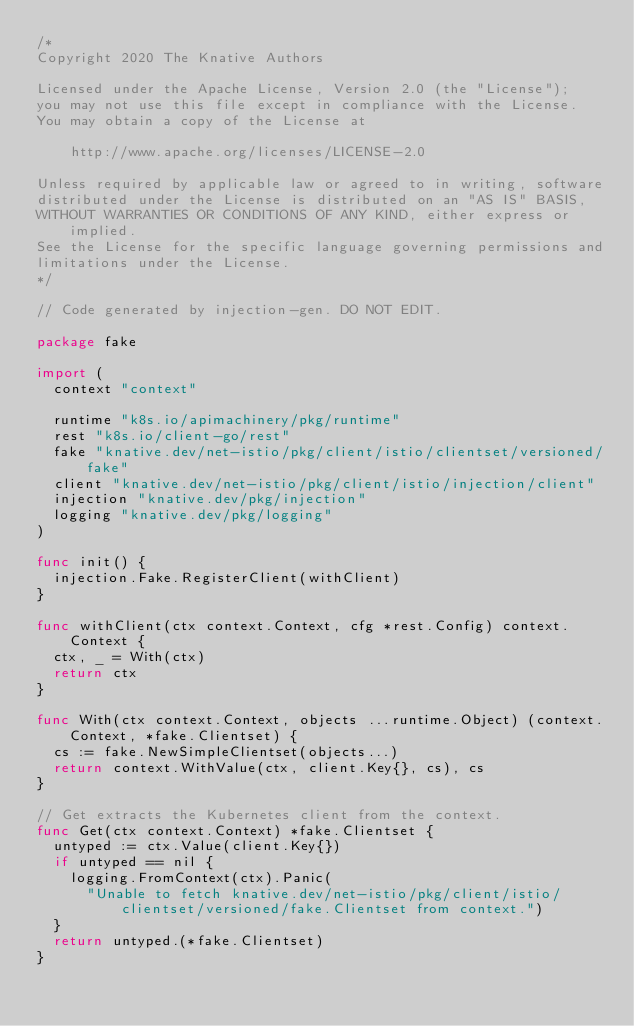Convert code to text. <code><loc_0><loc_0><loc_500><loc_500><_Go_>/*
Copyright 2020 The Knative Authors

Licensed under the Apache License, Version 2.0 (the "License");
you may not use this file except in compliance with the License.
You may obtain a copy of the License at

    http://www.apache.org/licenses/LICENSE-2.0

Unless required by applicable law or agreed to in writing, software
distributed under the License is distributed on an "AS IS" BASIS,
WITHOUT WARRANTIES OR CONDITIONS OF ANY KIND, either express or implied.
See the License for the specific language governing permissions and
limitations under the License.
*/

// Code generated by injection-gen. DO NOT EDIT.

package fake

import (
	context "context"

	runtime "k8s.io/apimachinery/pkg/runtime"
	rest "k8s.io/client-go/rest"
	fake "knative.dev/net-istio/pkg/client/istio/clientset/versioned/fake"
	client "knative.dev/net-istio/pkg/client/istio/injection/client"
	injection "knative.dev/pkg/injection"
	logging "knative.dev/pkg/logging"
)

func init() {
	injection.Fake.RegisterClient(withClient)
}

func withClient(ctx context.Context, cfg *rest.Config) context.Context {
	ctx, _ = With(ctx)
	return ctx
}

func With(ctx context.Context, objects ...runtime.Object) (context.Context, *fake.Clientset) {
	cs := fake.NewSimpleClientset(objects...)
	return context.WithValue(ctx, client.Key{}, cs), cs
}

// Get extracts the Kubernetes client from the context.
func Get(ctx context.Context) *fake.Clientset {
	untyped := ctx.Value(client.Key{})
	if untyped == nil {
		logging.FromContext(ctx).Panic(
			"Unable to fetch knative.dev/net-istio/pkg/client/istio/clientset/versioned/fake.Clientset from context.")
	}
	return untyped.(*fake.Clientset)
}
</code> 